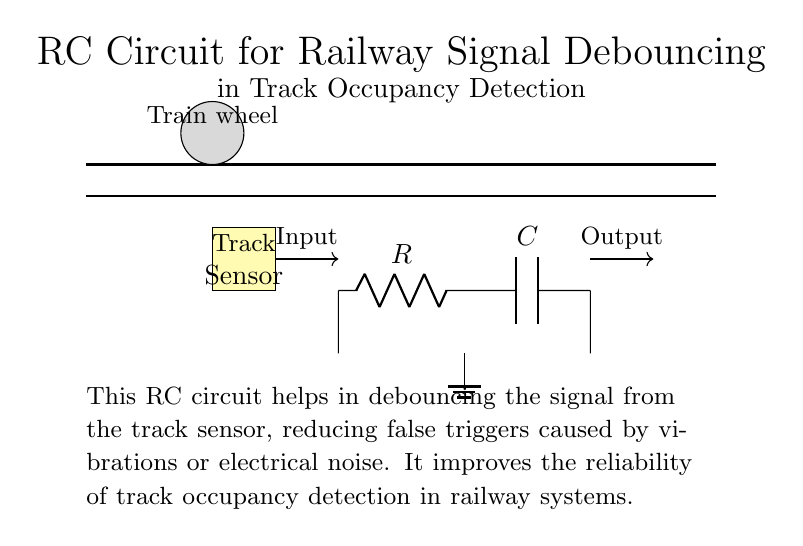What components are in this RC circuit? The circuit contains a resistor (R) and a capacitor (C), indicated by the symbols. These components are key in creating the RC time constant for the debouncing effect.
Answer: Resistor and capacitor What is the purpose of the RC circuit in this context? The RC circuit is designed to debounce the signal from the track sensor, which helps in minimizing false triggers due to noise or vibrations, ensuring reliable occupancy detection.
Answer: Debouncing the signal What is connected to the ground in this circuit? The ground is connected to the middle node between the resistor and capacitor, which helps stabilize the voltage level for the circuit operation. This is essential for proper functioning of the capacitor in discharging the signal.
Answer: Middle node between R and C What does the input signal represent in this circuit? The input signal comes from the track sensor, which detects train presence on the track and serves as the initial trigger for the circuit to process.
Answer: Train presence detection How does the capacitor influence the debouncing process? The capacitor charges and discharges over time, creating a delay in the output signal. This delay smooths out rapid fluctuations or noise in the input signal, allowing the circuit to provide a more stable output.
Answer: It smooths out fluctuations What is the expected effect of high capacitance in this circuit? A higher capacitance would increase the time constant of the circuit, meaning it would take longer for the capacitor to charge and discharge, further reducing the likelihood of false triggers from rapid signal changes.
Answer: Increases time constant What role does the resistor play in the RC circuit? The resistor limits the charge and discharge current of the capacitor, which determines the time it takes for the capacitor to charge to a certain voltage, essential for regulating the debouncing effect.
Answer: Regulates charge/discharge time 